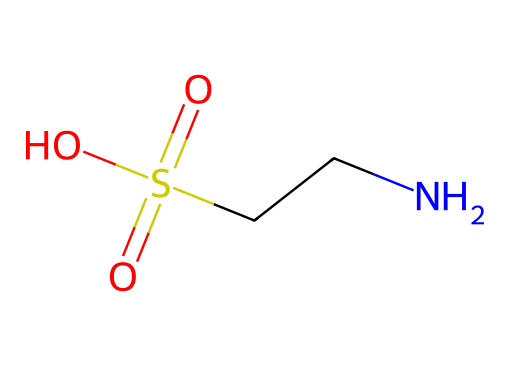What is the molecular formula of taurine? The molecular formula can be derived by counting the types of atoms in the SMILES representation. The components "NCCS(=O)(=O)O" indicate there is 1 nitrogen (N), 2 carbons (C), 1 sulfur (S), and 4 oxygens (O) in total. Therefore, the molecular formula is C2H7NO6S.
Answer: C2H7NO6S How many sulfur atoms are present in taurine? The SMILES representation contains "S" which indicates the presence of one sulfur atom in its molecular structure.
Answer: 1 What type of functional groups are present in taurine? Analyzing the SMILES notation reveals the presence of a sulfonic acid group (-S(=O)(=O)O) and an amine group (-NH2) connected to the carbon chain. These groups contribute to the chemical's properties.
Answer: sulfonic acid, amine What is the total number of oxygen atoms in taurine? Counting the "=" and "O" in the SMILES string shows there are three oxygens in the sulfonic acid group and one hydroxyl (-OH) group, giving a total of four oxygen atoms.
Answer: 4 What is the primary biological role of taurine? Taurine is known for its role in bile salt formation, osmoregulation, and as a neurotransmitter, contributing to cellular stability and signaling in the body.
Answer: neurotransmitter Does taurine have any chiral centers? Looking at the structure represented in the SMILES notation and analyzing the carbon atoms reveals that none of the carbon atoms are bonded to four different substituents, indicating no chiral centers are present.
Answer: No 